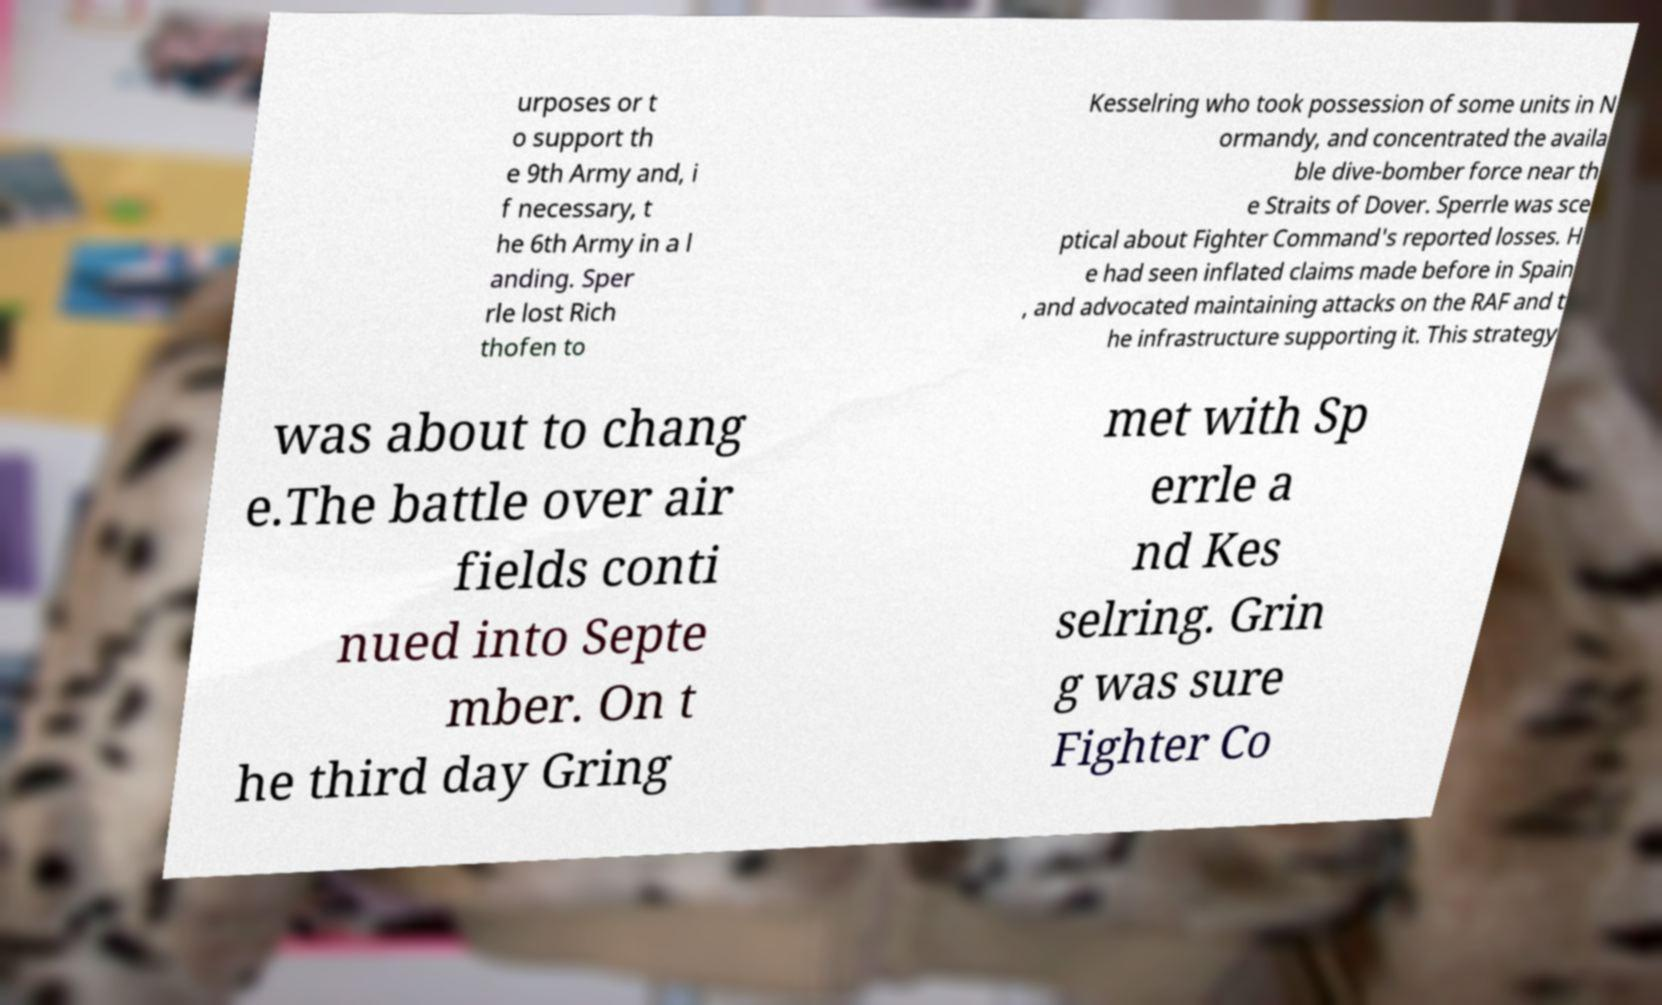There's text embedded in this image that I need extracted. Can you transcribe it verbatim? urposes or t o support th e 9th Army and, i f necessary, t he 6th Army in a l anding. Sper rle lost Rich thofen to Kesselring who took possession of some units in N ormandy, and concentrated the availa ble dive-bomber force near th e Straits of Dover. Sperrle was sce ptical about Fighter Command's reported losses. H e had seen inflated claims made before in Spain , and advocated maintaining attacks on the RAF and t he infrastructure supporting it. This strategy was about to chang e.The battle over air fields conti nued into Septe mber. On t he third day Gring met with Sp errle a nd Kes selring. Grin g was sure Fighter Co 